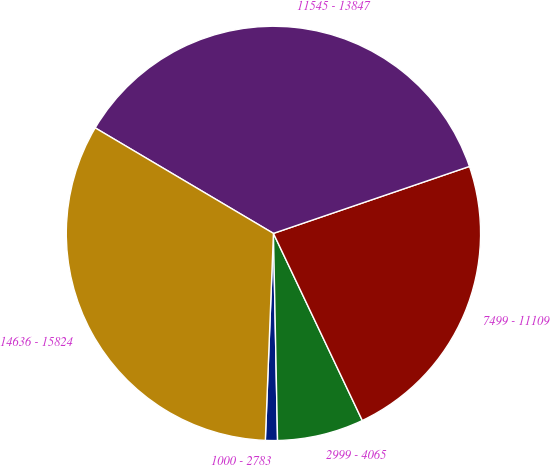Convert chart. <chart><loc_0><loc_0><loc_500><loc_500><pie_chart><fcel>1000 - 2783<fcel>2999 - 4065<fcel>7499 - 11109<fcel>11545 - 13847<fcel>14636 - 15824<nl><fcel>0.94%<fcel>6.74%<fcel>23.18%<fcel>36.25%<fcel>32.88%<nl></chart> 